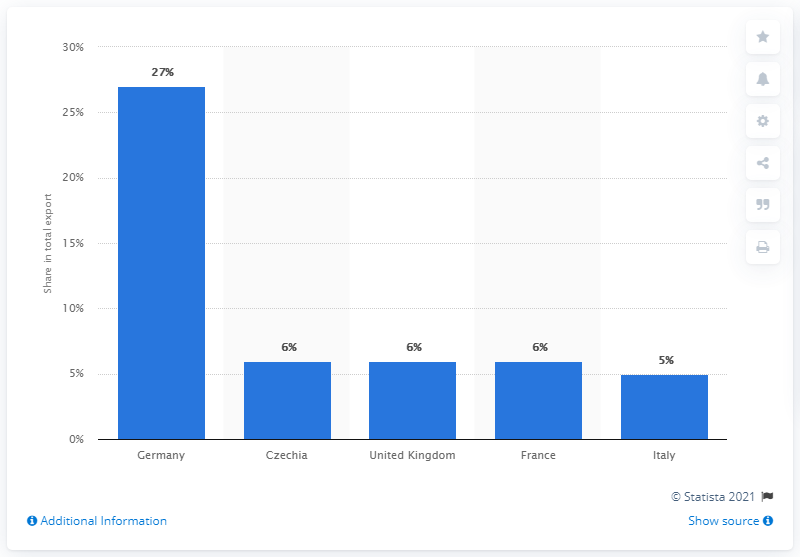Identify some key points in this picture. Poland's most significant export partner in 2019 was Germany. 